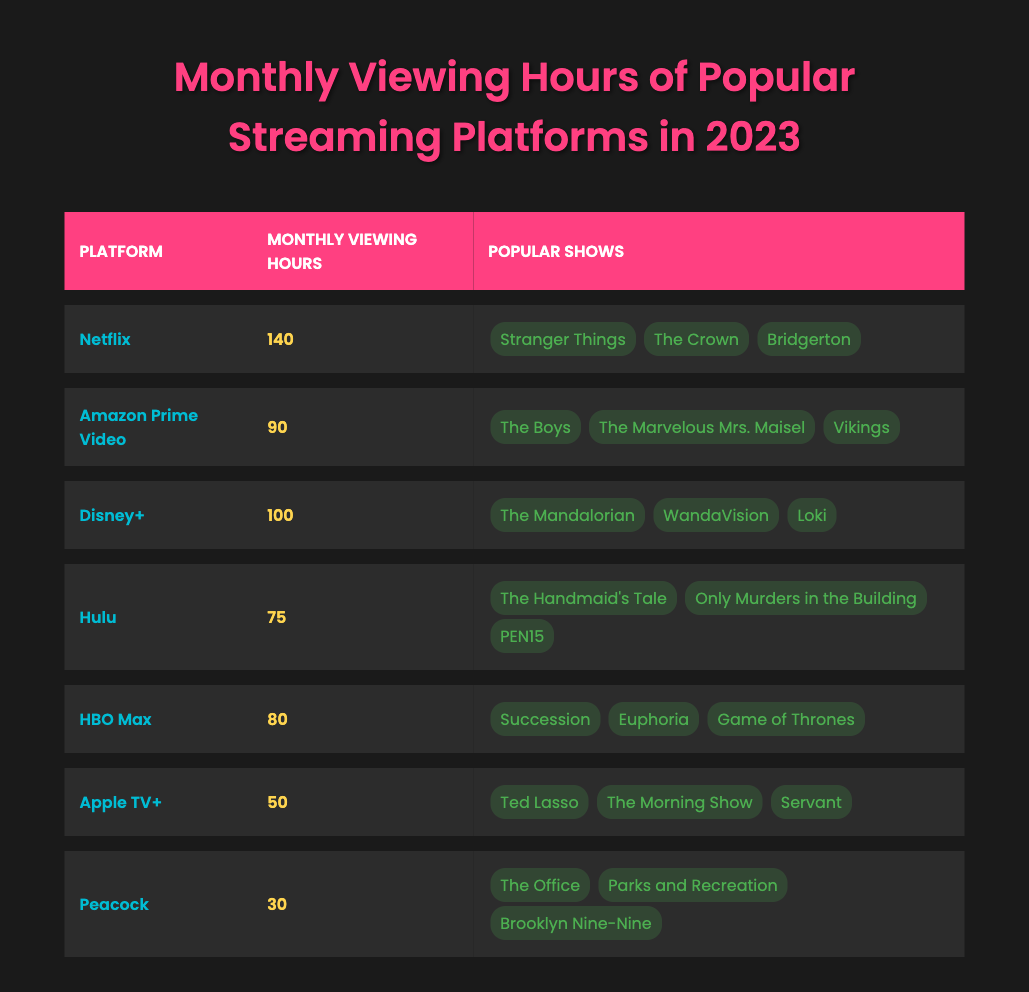What is the platform with the highest monthly viewing hours? By looking at the table, Netflix shows 140 monthly viewing hours, which is more than any other platform listed.
Answer: Netflix How many monthly viewing hours does Hulu have? The table indicates that Hulu has 75 monthly viewing hours.
Answer: 75 Which platform has fewer monthly viewing hours, Apple TV+ or Peacock? Apple TV+ has 50 hours while Peacock has 30 hours, which means Peacock has fewer hours.
Answer: Peacock What are the three popular shows on Disney+? The table lists "The Mandalorian," "WandaVision," and "Loki" as the popular shows on Disney+.
Answer: The Mandalorian, WandaVision, Loki What is the average monthly viewing hours across all platforms? The total monthly viewing hours are calculated as follows: 140 + 90 + 100 + 75 + 80 + 50 + 30 = 565. The average is 565/7 = 80.71, rounded to two decimal places.
Answer: 80.71 Is it true that HBO Max has more monthly viewing hours than Hulu? HBO Max has 80 monthly viewing hours while Hulu has 75, so HBO Max does have more hours.
Answer: Yes How many more viewing hours does Netflix have compared to Apple TV+? Netflix has 140 hours and Apple TV+ has 50 hours. The difference is 140 - 50 = 90 hours.
Answer: 90 Which platform has the lowest monthly viewing hours and what are its popular shows? The platform with the lowest hours is Peacock, which has 30 monthly viewing hours, and its popular shows are "The Office," "Parks and Recreation," and "Brooklyn Nine-Nine."
Answer: Peacock; The Office, Parks and Recreation, Brooklyn Nine-Nine If you combine the viewing hours of Amazon Prime Video and Disney+, what is the total? Amazon Prime Video has 90 hours and Disney+ has 100 hours. The total is 90 + 100 = 190 hours.
Answer: 190 Which platform has the maximum number of shows listed, and what are they? Netflix, Amazon Prime Video, and Disney+ each have three shows listed, which is the maximum among all platforms.
Answer: Netflix, Amazon Prime Video, Disney+ (3 shows each) 